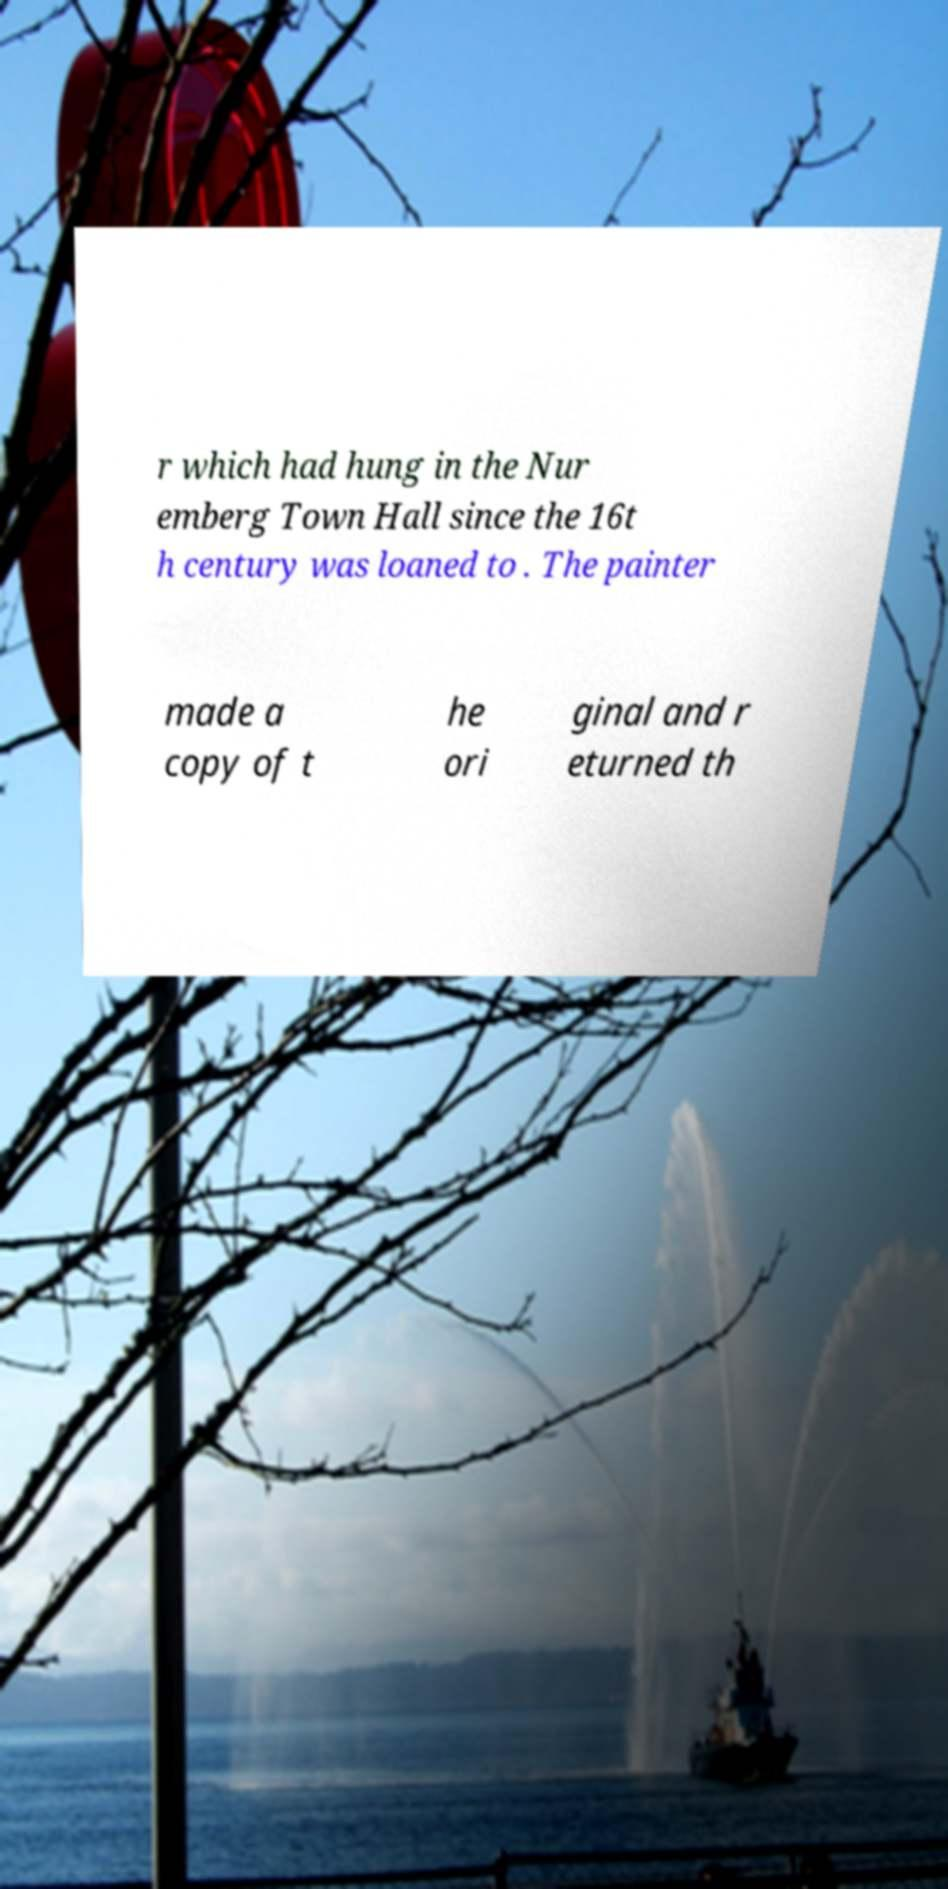Can you accurately transcribe the text from the provided image for me? r which had hung in the Nur emberg Town Hall since the 16t h century was loaned to . The painter made a copy of t he ori ginal and r eturned th 